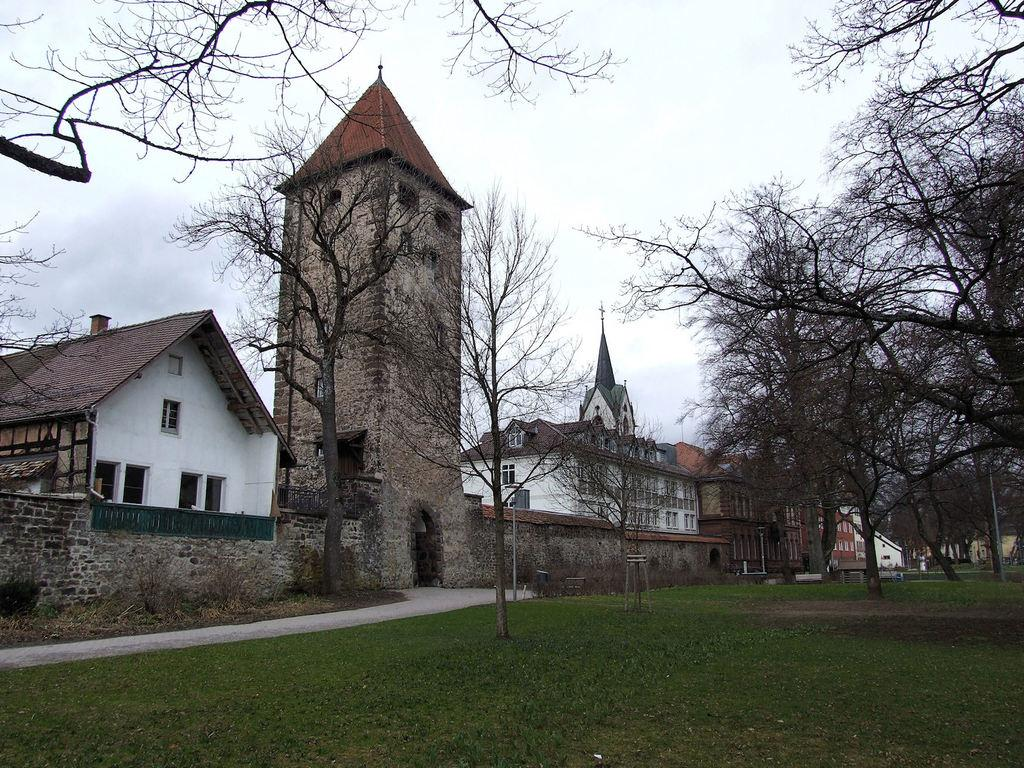What type of vegetation can be seen in the image? There are trees in the image. What type of structures are visible in the image? There are houses and a tower in the image. What architectural feature can be seen in the image? There is a wall in the image. What type of pathway is present in the image? There is a road in the image. What type of ground cover is visible in the image? There is grass in the image. What is visible in the sky in the image? The sky is visible in the image, and there are clouds present. What type of oatmeal is being served in the image? There is no oatmeal present in the image. What type of carriage can be seen transporting cattle in the image? There is no carriage or cattle present in the image. 